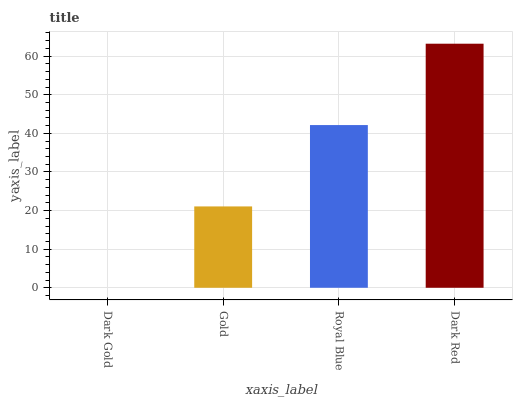Is Dark Gold the minimum?
Answer yes or no. Yes. Is Dark Red the maximum?
Answer yes or no. Yes. Is Gold the minimum?
Answer yes or no. No. Is Gold the maximum?
Answer yes or no. No. Is Gold greater than Dark Gold?
Answer yes or no. Yes. Is Dark Gold less than Gold?
Answer yes or no. Yes. Is Dark Gold greater than Gold?
Answer yes or no. No. Is Gold less than Dark Gold?
Answer yes or no. No. Is Royal Blue the high median?
Answer yes or no. Yes. Is Gold the low median?
Answer yes or no. Yes. Is Dark Red the high median?
Answer yes or no. No. Is Dark Gold the low median?
Answer yes or no. No. 